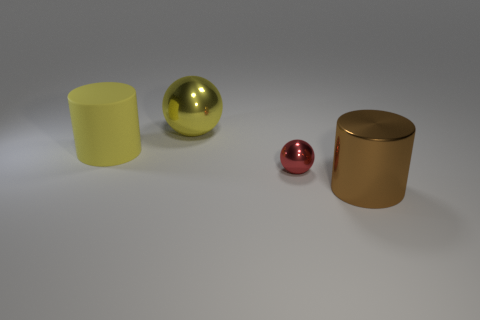Subtract all yellow spheres. How many spheres are left? 1 Add 4 tiny red things. How many objects exist? 8 Add 4 big shiny things. How many big shiny things are left? 6 Add 4 small red balls. How many small red balls exist? 5 Subtract 1 red spheres. How many objects are left? 3 Subtract 1 cylinders. How many cylinders are left? 1 Subtract all brown cylinders. Subtract all brown cubes. How many cylinders are left? 1 Subtract all yellow spheres. How many brown cylinders are left? 1 Subtract all large yellow metal balls. Subtract all small metal cylinders. How many objects are left? 3 